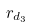<formula> <loc_0><loc_0><loc_500><loc_500>r _ { d _ { 3 } }</formula> 